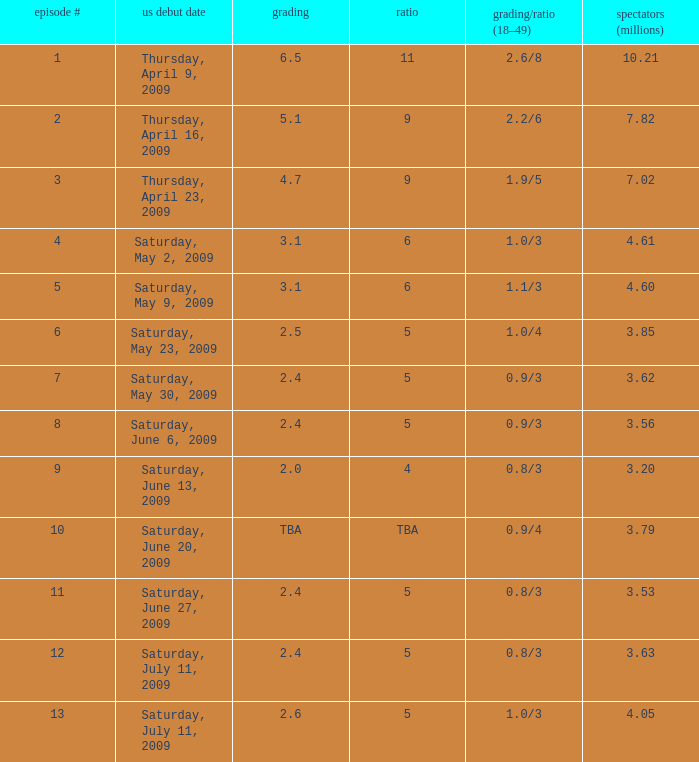What is the average number of million viewers that watched an episode before episode 11 with a share of 4? 3.2. 